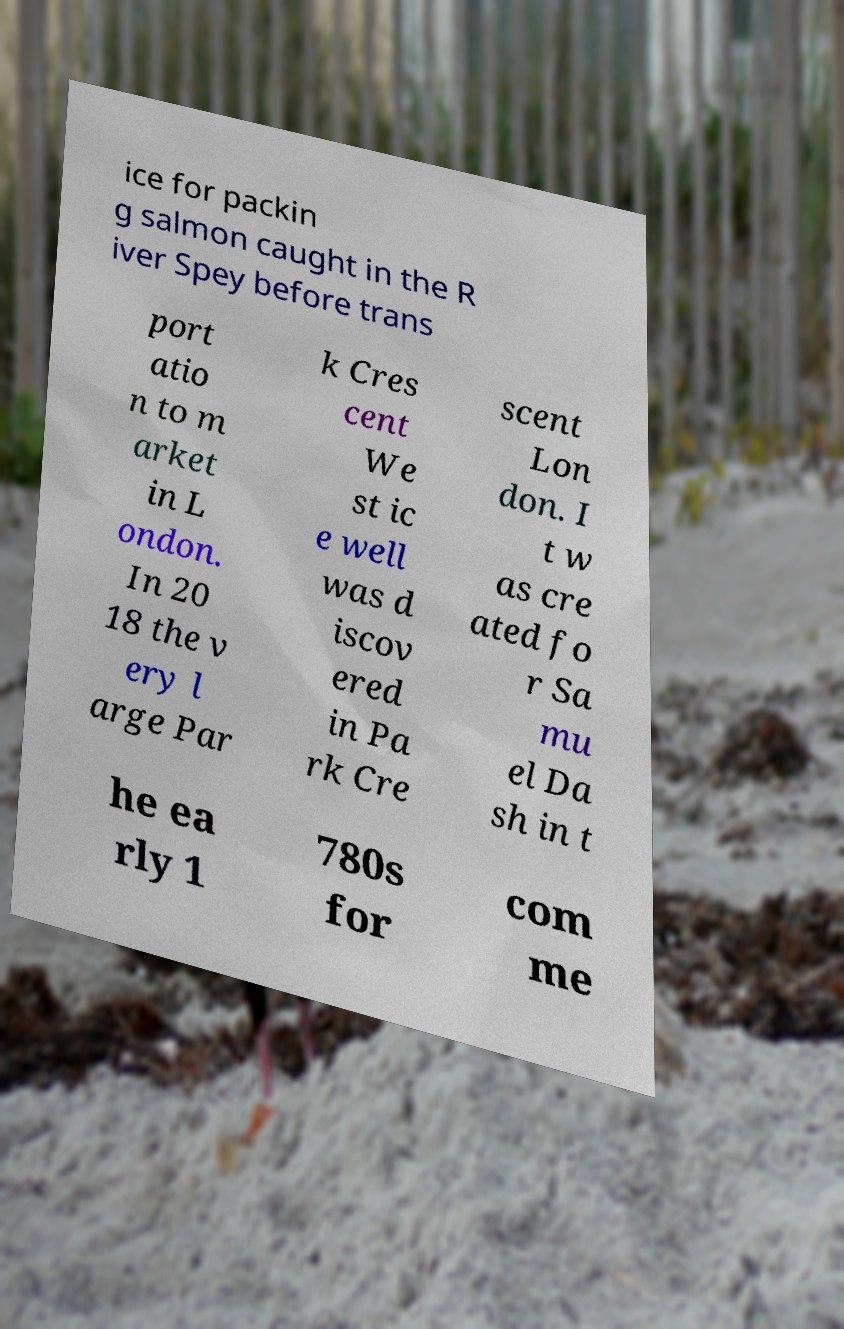Can you read and provide the text displayed in the image?This photo seems to have some interesting text. Can you extract and type it out for me? ice for packin g salmon caught in the R iver Spey before trans port atio n to m arket in L ondon. In 20 18 the v ery l arge Par k Cres cent We st ic e well was d iscov ered in Pa rk Cre scent Lon don. I t w as cre ated fo r Sa mu el Da sh in t he ea rly 1 780s for com me 